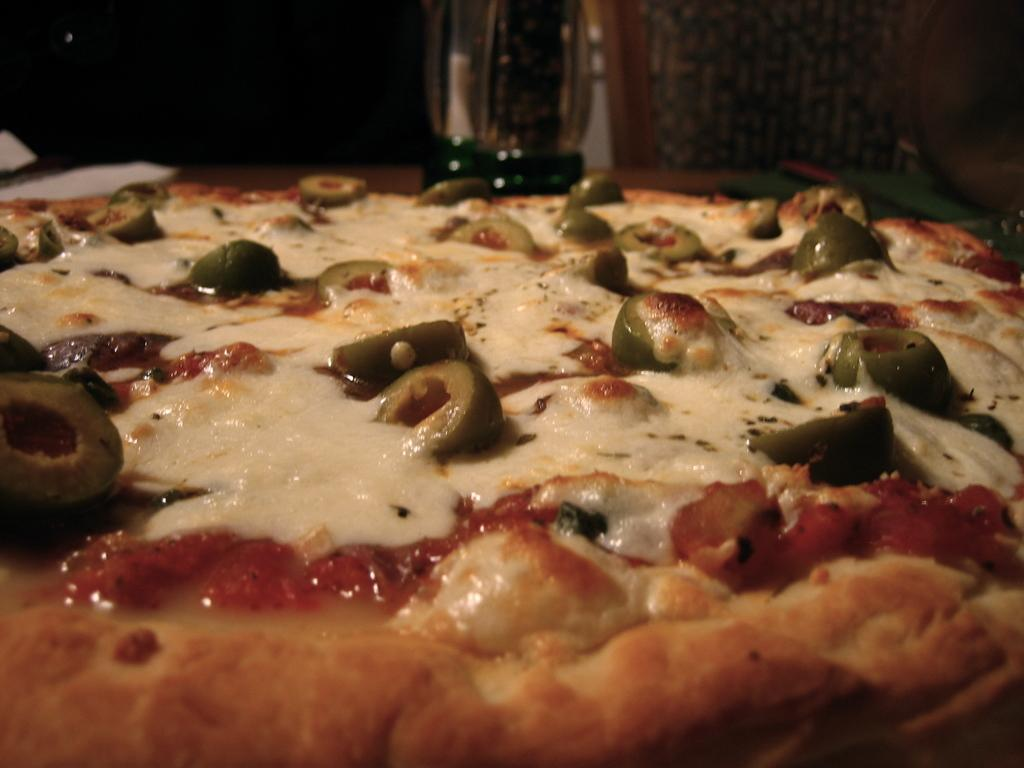What type of food is shown in the image? There is a pizza in the image. Can you describe any other elements in the image besides the pizza? There are objects visible in the dark at the top of the image. How does the pizza adjust its temperature in the image? The pizza does not adjust its temperature in the image; it is a static image and not a real pizza. 